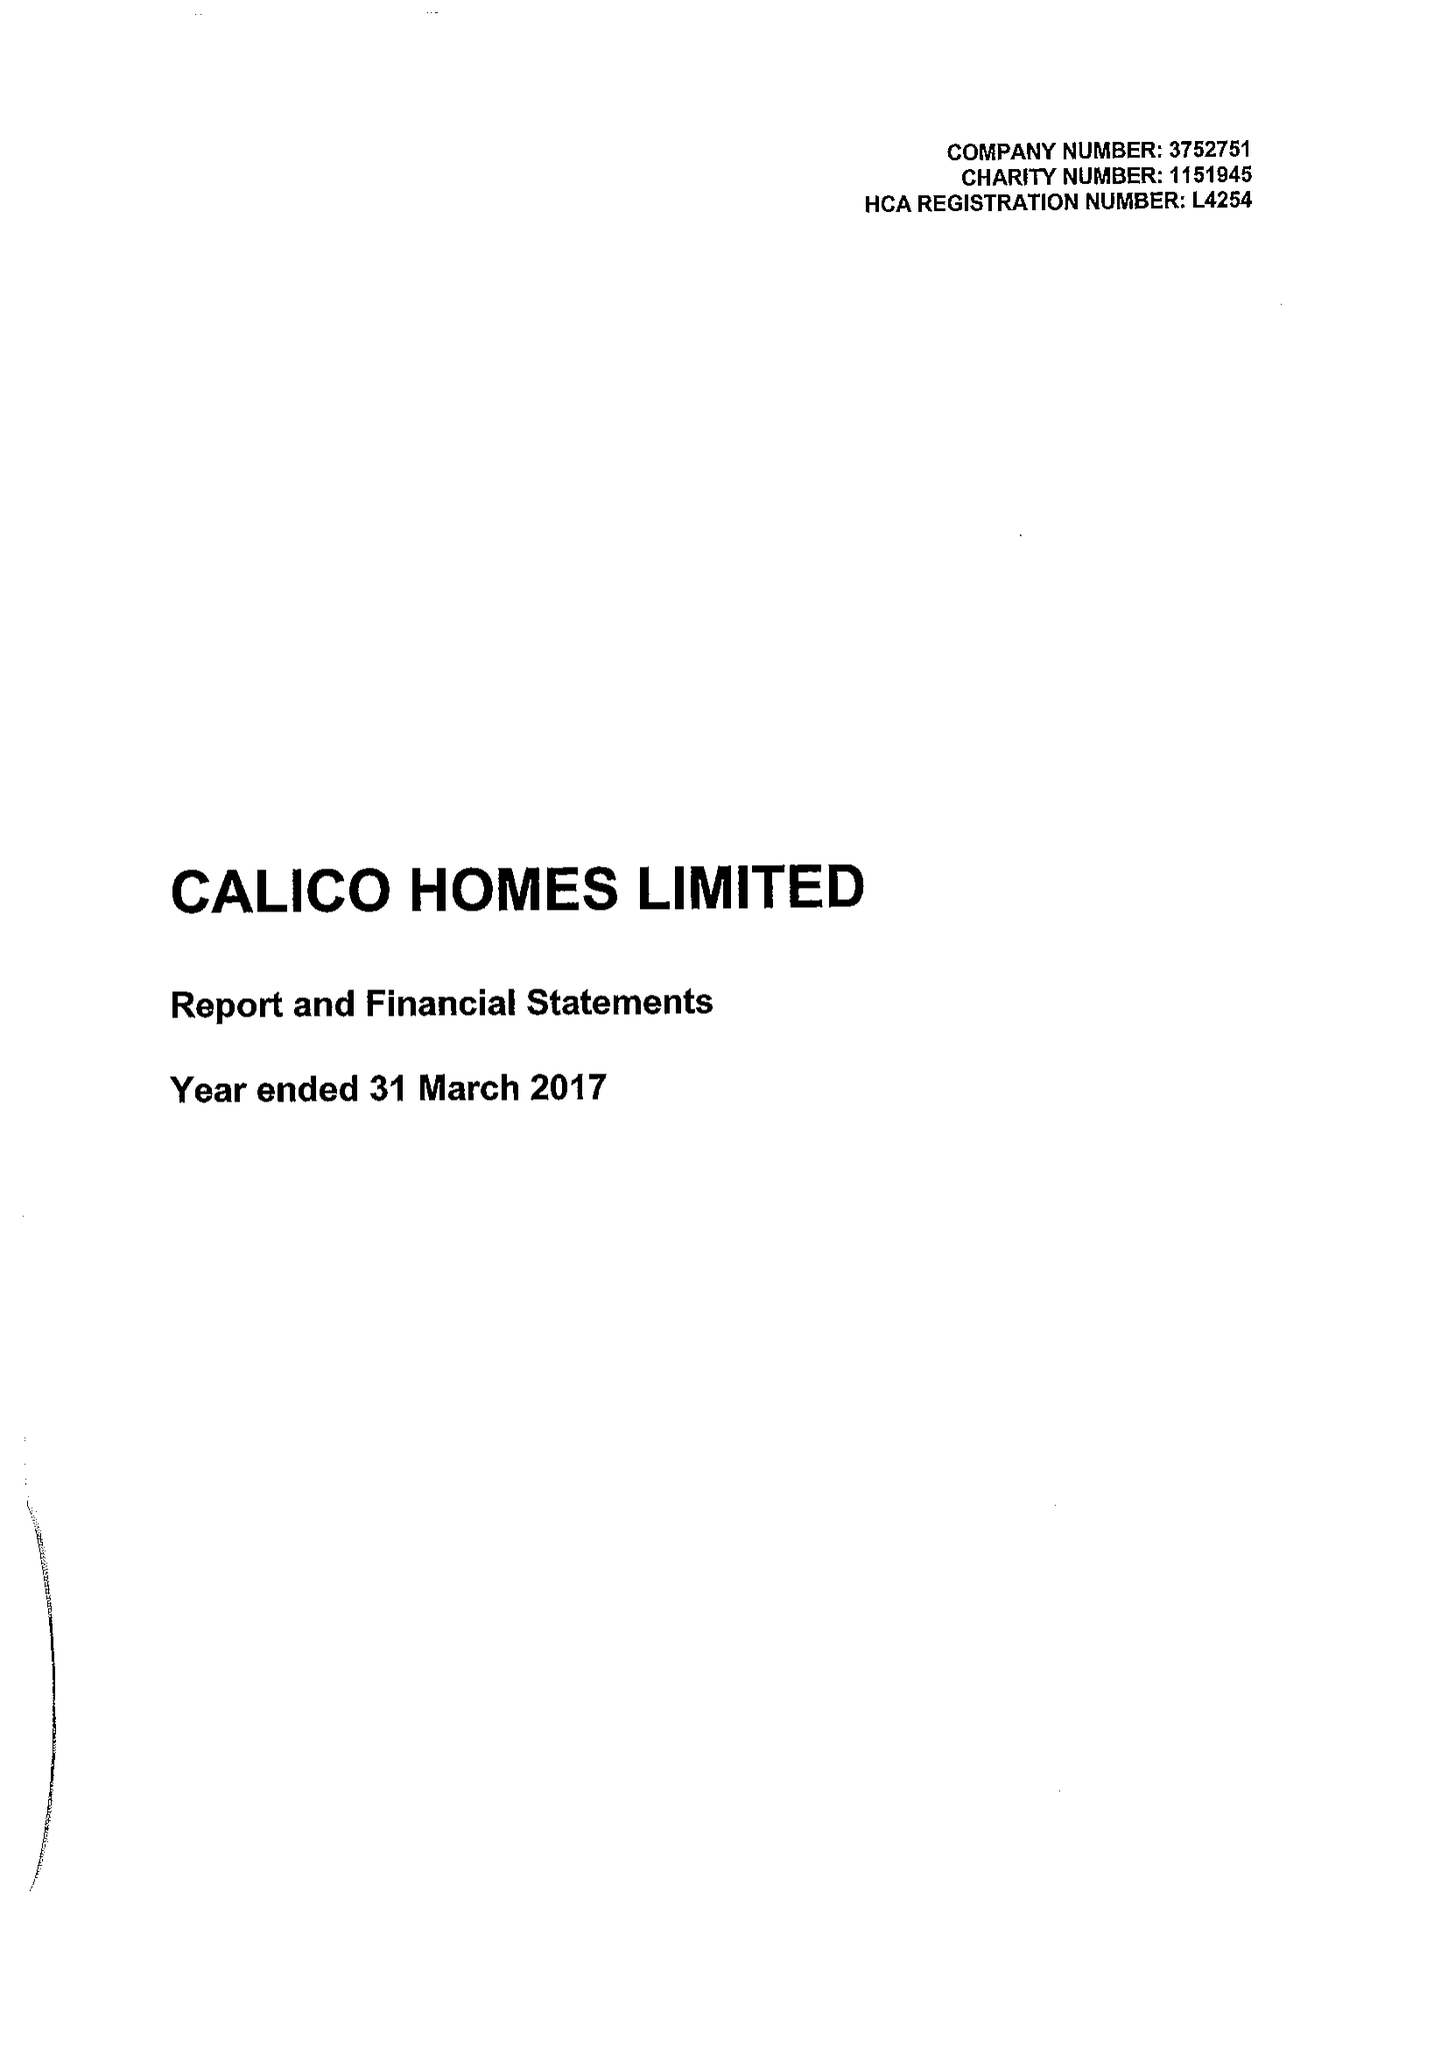What is the value for the report_date?
Answer the question using a single word or phrase. 2017-03-31 